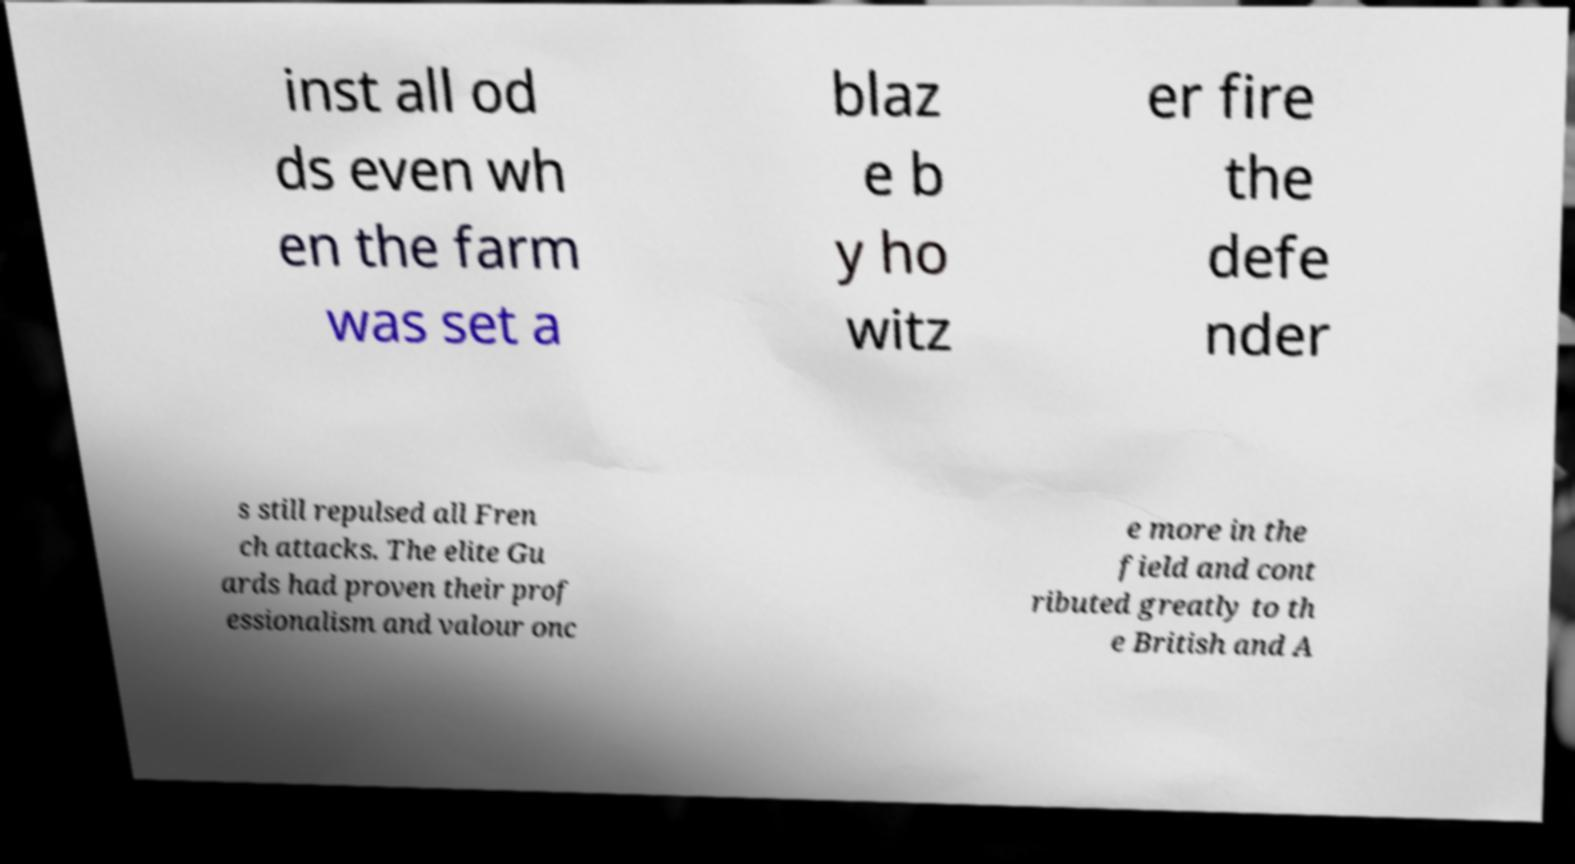I need the written content from this picture converted into text. Can you do that? inst all od ds even wh en the farm was set a blaz e b y ho witz er fire the defe nder s still repulsed all Fren ch attacks. The elite Gu ards had proven their prof essionalism and valour onc e more in the field and cont ributed greatly to th e British and A 